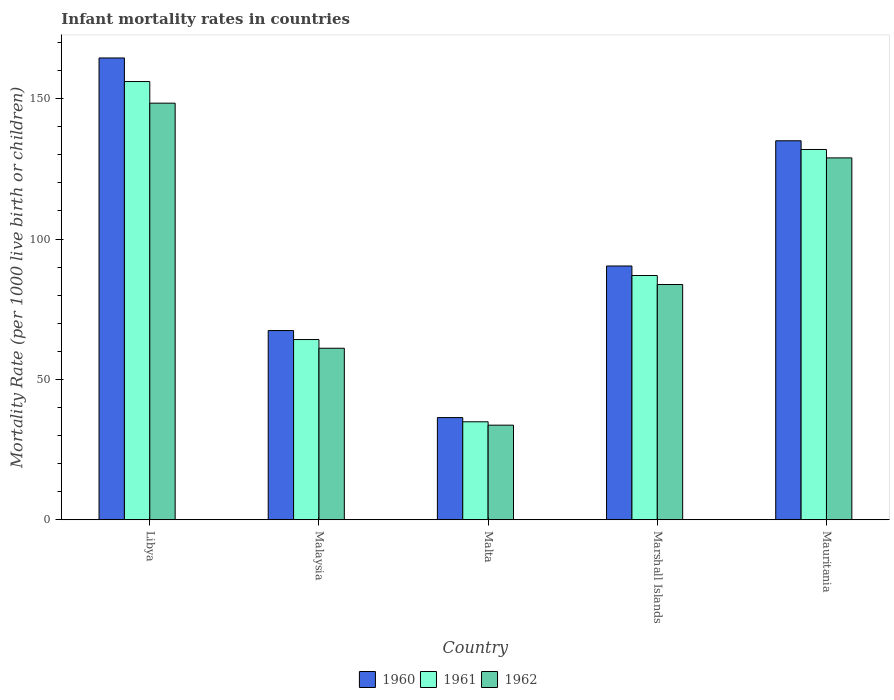How many groups of bars are there?
Give a very brief answer. 5. What is the label of the 1st group of bars from the left?
Provide a short and direct response. Libya. In how many cases, is the number of bars for a given country not equal to the number of legend labels?
Make the answer very short. 0. What is the infant mortality rate in 1962 in Marshall Islands?
Your response must be concise. 83.8. Across all countries, what is the maximum infant mortality rate in 1961?
Your answer should be compact. 156.1. Across all countries, what is the minimum infant mortality rate in 1960?
Provide a short and direct response. 36.4. In which country was the infant mortality rate in 1960 maximum?
Your answer should be compact. Libya. In which country was the infant mortality rate in 1960 minimum?
Offer a terse response. Malta. What is the total infant mortality rate in 1961 in the graph?
Make the answer very short. 474.1. What is the difference between the infant mortality rate in 1962 in Malta and that in Mauritania?
Offer a terse response. -95.2. What is the difference between the infant mortality rate in 1960 in Marshall Islands and the infant mortality rate in 1962 in Libya?
Provide a short and direct response. -58. What is the average infant mortality rate in 1961 per country?
Give a very brief answer. 94.82. What is the difference between the infant mortality rate of/in 1962 and infant mortality rate of/in 1960 in Libya?
Keep it short and to the point. -16.1. In how many countries, is the infant mortality rate in 1962 greater than 160?
Your answer should be very brief. 0. What is the ratio of the infant mortality rate in 1962 in Malaysia to that in Mauritania?
Provide a short and direct response. 0.47. What is the difference between the highest and the second highest infant mortality rate in 1962?
Your answer should be very brief. 45.1. What is the difference between the highest and the lowest infant mortality rate in 1960?
Your answer should be compact. 128.1. In how many countries, is the infant mortality rate in 1961 greater than the average infant mortality rate in 1961 taken over all countries?
Give a very brief answer. 2. Is the sum of the infant mortality rate in 1962 in Malaysia and Mauritania greater than the maximum infant mortality rate in 1961 across all countries?
Provide a short and direct response. Yes. How many countries are there in the graph?
Provide a short and direct response. 5. What is the difference between two consecutive major ticks on the Y-axis?
Provide a succinct answer. 50. Where does the legend appear in the graph?
Provide a succinct answer. Bottom center. How many legend labels are there?
Make the answer very short. 3. What is the title of the graph?
Your answer should be very brief. Infant mortality rates in countries. Does "1995" appear as one of the legend labels in the graph?
Keep it short and to the point. No. What is the label or title of the X-axis?
Make the answer very short. Country. What is the label or title of the Y-axis?
Give a very brief answer. Mortality Rate (per 1000 live birth or children). What is the Mortality Rate (per 1000 live birth or children) of 1960 in Libya?
Your response must be concise. 164.5. What is the Mortality Rate (per 1000 live birth or children) in 1961 in Libya?
Offer a terse response. 156.1. What is the Mortality Rate (per 1000 live birth or children) in 1962 in Libya?
Offer a terse response. 148.4. What is the Mortality Rate (per 1000 live birth or children) of 1960 in Malaysia?
Your answer should be very brief. 67.4. What is the Mortality Rate (per 1000 live birth or children) in 1961 in Malaysia?
Your answer should be very brief. 64.2. What is the Mortality Rate (per 1000 live birth or children) in 1962 in Malaysia?
Offer a very short reply. 61.1. What is the Mortality Rate (per 1000 live birth or children) in 1960 in Malta?
Provide a short and direct response. 36.4. What is the Mortality Rate (per 1000 live birth or children) in 1961 in Malta?
Provide a succinct answer. 34.9. What is the Mortality Rate (per 1000 live birth or children) in 1962 in Malta?
Provide a short and direct response. 33.7. What is the Mortality Rate (per 1000 live birth or children) of 1960 in Marshall Islands?
Make the answer very short. 90.4. What is the Mortality Rate (per 1000 live birth or children) in 1962 in Marshall Islands?
Your answer should be very brief. 83.8. What is the Mortality Rate (per 1000 live birth or children) in 1960 in Mauritania?
Make the answer very short. 135. What is the Mortality Rate (per 1000 live birth or children) in 1961 in Mauritania?
Offer a terse response. 131.9. What is the Mortality Rate (per 1000 live birth or children) of 1962 in Mauritania?
Offer a very short reply. 128.9. Across all countries, what is the maximum Mortality Rate (per 1000 live birth or children) of 1960?
Your response must be concise. 164.5. Across all countries, what is the maximum Mortality Rate (per 1000 live birth or children) in 1961?
Offer a very short reply. 156.1. Across all countries, what is the maximum Mortality Rate (per 1000 live birth or children) of 1962?
Provide a short and direct response. 148.4. Across all countries, what is the minimum Mortality Rate (per 1000 live birth or children) of 1960?
Your response must be concise. 36.4. Across all countries, what is the minimum Mortality Rate (per 1000 live birth or children) in 1961?
Your response must be concise. 34.9. Across all countries, what is the minimum Mortality Rate (per 1000 live birth or children) in 1962?
Provide a succinct answer. 33.7. What is the total Mortality Rate (per 1000 live birth or children) in 1960 in the graph?
Offer a very short reply. 493.7. What is the total Mortality Rate (per 1000 live birth or children) of 1961 in the graph?
Offer a terse response. 474.1. What is the total Mortality Rate (per 1000 live birth or children) of 1962 in the graph?
Ensure brevity in your answer.  455.9. What is the difference between the Mortality Rate (per 1000 live birth or children) in 1960 in Libya and that in Malaysia?
Keep it short and to the point. 97.1. What is the difference between the Mortality Rate (per 1000 live birth or children) of 1961 in Libya and that in Malaysia?
Provide a short and direct response. 91.9. What is the difference between the Mortality Rate (per 1000 live birth or children) in 1962 in Libya and that in Malaysia?
Keep it short and to the point. 87.3. What is the difference between the Mortality Rate (per 1000 live birth or children) of 1960 in Libya and that in Malta?
Your response must be concise. 128.1. What is the difference between the Mortality Rate (per 1000 live birth or children) in 1961 in Libya and that in Malta?
Provide a short and direct response. 121.2. What is the difference between the Mortality Rate (per 1000 live birth or children) of 1962 in Libya and that in Malta?
Your answer should be compact. 114.7. What is the difference between the Mortality Rate (per 1000 live birth or children) in 1960 in Libya and that in Marshall Islands?
Your answer should be compact. 74.1. What is the difference between the Mortality Rate (per 1000 live birth or children) of 1961 in Libya and that in Marshall Islands?
Offer a terse response. 69.1. What is the difference between the Mortality Rate (per 1000 live birth or children) in 1962 in Libya and that in Marshall Islands?
Your answer should be compact. 64.6. What is the difference between the Mortality Rate (per 1000 live birth or children) of 1960 in Libya and that in Mauritania?
Keep it short and to the point. 29.5. What is the difference between the Mortality Rate (per 1000 live birth or children) in 1961 in Libya and that in Mauritania?
Offer a terse response. 24.2. What is the difference between the Mortality Rate (per 1000 live birth or children) in 1961 in Malaysia and that in Malta?
Make the answer very short. 29.3. What is the difference between the Mortality Rate (per 1000 live birth or children) in 1962 in Malaysia and that in Malta?
Make the answer very short. 27.4. What is the difference between the Mortality Rate (per 1000 live birth or children) in 1960 in Malaysia and that in Marshall Islands?
Your answer should be very brief. -23. What is the difference between the Mortality Rate (per 1000 live birth or children) in 1961 in Malaysia and that in Marshall Islands?
Offer a terse response. -22.8. What is the difference between the Mortality Rate (per 1000 live birth or children) in 1962 in Malaysia and that in Marshall Islands?
Ensure brevity in your answer.  -22.7. What is the difference between the Mortality Rate (per 1000 live birth or children) of 1960 in Malaysia and that in Mauritania?
Provide a short and direct response. -67.6. What is the difference between the Mortality Rate (per 1000 live birth or children) of 1961 in Malaysia and that in Mauritania?
Your answer should be compact. -67.7. What is the difference between the Mortality Rate (per 1000 live birth or children) in 1962 in Malaysia and that in Mauritania?
Your answer should be very brief. -67.8. What is the difference between the Mortality Rate (per 1000 live birth or children) of 1960 in Malta and that in Marshall Islands?
Your answer should be very brief. -54. What is the difference between the Mortality Rate (per 1000 live birth or children) of 1961 in Malta and that in Marshall Islands?
Your answer should be compact. -52.1. What is the difference between the Mortality Rate (per 1000 live birth or children) of 1962 in Malta and that in Marshall Islands?
Your answer should be very brief. -50.1. What is the difference between the Mortality Rate (per 1000 live birth or children) in 1960 in Malta and that in Mauritania?
Provide a succinct answer. -98.6. What is the difference between the Mortality Rate (per 1000 live birth or children) in 1961 in Malta and that in Mauritania?
Offer a very short reply. -97. What is the difference between the Mortality Rate (per 1000 live birth or children) in 1962 in Malta and that in Mauritania?
Offer a terse response. -95.2. What is the difference between the Mortality Rate (per 1000 live birth or children) in 1960 in Marshall Islands and that in Mauritania?
Keep it short and to the point. -44.6. What is the difference between the Mortality Rate (per 1000 live birth or children) of 1961 in Marshall Islands and that in Mauritania?
Provide a succinct answer. -44.9. What is the difference between the Mortality Rate (per 1000 live birth or children) in 1962 in Marshall Islands and that in Mauritania?
Your response must be concise. -45.1. What is the difference between the Mortality Rate (per 1000 live birth or children) in 1960 in Libya and the Mortality Rate (per 1000 live birth or children) in 1961 in Malaysia?
Your answer should be compact. 100.3. What is the difference between the Mortality Rate (per 1000 live birth or children) of 1960 in Libya and the Mortality Rate (per 1000 live birth or children) of 1962 in Malaysia?
Offer a very short reply. 103.4. What is the difference between the Mortality Rate (per 1000 live birth or children) in 1960 in Libya and the Mortality Rate (per 1000 live birth or children) in 1961 in Malta?
Make the answer very short. 129.6. What is the difference between the Mortality Rate (per 1000 live birth or children) in 1960 in Libya and the Mortality Rate (per 1000 live birth or children) in 1962 in Malta?
Make the answer very short. 130.8. What is the difference between the Mortality Rate (per 1000 live birth or children) of 1961 in Libya and the Mortality Rate (per 1000 live birth or children) of 1962 in Malta?
Offer a very short reply. 122.4. What is the difference between the Mortality Rate (per 1000 live birth or children) in 1960 in Libya and the Mortality Rate (per 1000 live birth or children) in 1961 in Marshall Islands?
Provide a short and direct response. 77.5. What is the difference between the Mortality Rate (per 1000 live birth or children) in 1960 in Libya and the Mortality Rate (per 1000 live birth or children) in 1962 in Marshall Islands?
Provide a succinct answer. 80.7. What is the difference between the Mortality Rate (per 1000 live birth or children) in 1961 in Libya and the Mortality Rate (per 1000 live birth or children) in 1962 in Marshall Islands?
Keep it short and to the point. 72.3. What is the difference between the Mortality Rate (per 1000 live birth or children) of 1960 in Libya and the Mortality Rate (per 1000 live birth or children) of 1961 in Mauritania?
Give a very brief answer. 32.6. What is the difference between the Mortality Rate (per 1000 live birth or children) in 1960 in Libya and the Mortality Rate (per 1000 live birth or children) in 1962 in Mauritania?
Ensure brevity in your answer.  35.6. What is the difference between the Mortality Rate (per 1000 live birth or children) in 1961 in Libya and the Mortality Rate (per 1000 live birth or children) in 1962 in Mauritania?
Your answer should be compact. 27.2. What is the difference between the Mortality Rate (per 1000 live birth or children) in 1960 in Malaysia and the Mortality Rate (per 1000 live birth or children) in 1961 in Malta?
Provide a succinct answer. 32.5. What is the difference between the Mortality Rate (per 1000 live birth or children) of 1960 in Malaysia and the Mortality Rate (per 1000 live birth or children) of 1962 in Malta?
Your answer should be very brief. 33.7. What is the difference between the Mortality Rate (per 1000 live birth or children) in 1961 in Malaysia and the Mortality Rate (per 1000 live birth or children) in 1962 in Malta?
Keep it short and to the point. 30.5. What is the difference between the Mortality Rate (per 1000 live birth or children) of 1960 in Malaysia and the Mortality Rate (per 1000 live birth or children) of 1961 in Marshall Islands?
Your response must be concise. -19.6. What is the difference between the Mortality Rate (per 1000 live birth or children) of 1960 in Malaysia and the Mortality Rate (per 1000 live birth or children) of 1962 in Marshall Islands?
Your answer should be compact. -16.4. What is the difference between the Mortality Rate (per 1000 live birth or children) in 1961 in Malaysia and the Mortality Rate (per 1000 live birth or children) in 1962 in Marshall Islands?
Provide a succinct answer. -19.6. What is the difference between the Mortality Rate (per 1000 live birth or children) of 1960 in Malaysia and the Mortality Rate (per 1000 live birth or children) of 1961 in Mauritania?
Offer a very short reply. -64.5. What is the difference between the Mortality Rate (per 1000 live birth or children) of 1960 in Malaysia and the Mortality Rate (per 1000 live birth or children) of 1962 in Mauritania?
Provide a short and direct response. -61.5. What is the difference between the Mortality Rate (per 1000 live birth or children) of 1961 in Malaysia and the Mortality Rate (per 1000 live birth or children) of 1962 in Mauritania?
Ensure brevity in your answer.  -64.7. What is the difference between the Mortality Rate (per 1000 live birth or children) in 1960 in Malta and the Mortality Rate (per 1000 live birth or children) in 1961 in Marshall Islands?
Provide a succinct answer. -50.6. What is the difference between the Mortality Rate (per 1000 live birth or children) of 1960 in Malta and the Mortality Rate (per 1000 live birth or children) of 1962 in Marshall Islands?
Make the answer very short. -47.4. What is the difference between the Mortality Rate (per 1000 live birth or children) in 1961 in Malta and the Mortality Rate (per 1000 live birth or children) in 1962 in Marshall Islands?
Your answer should be very brief. -48.9. What is the difference between the Mortality Rate (per 1000 live birth or children) in 1960 in Malta and the Mortality Rate (per 1000 live birth or children) in 1961 in Mauritania?
Keep it short and to the point. -95.5. What is the difference between the Mortality Rate (per 1000 live birth or children) in 1960 in Malta and the Mortality Rate (per 1000 live birth or children) in 1962 in Mauritania?
Make the answer very short. -92.5. What is the difference between the Mortality Rate (per 1000 live birth or children) in 1961 in Malta and the Mortality Rate (per 1000 live birth or children) in 1962 in Mauritania?
Offer a very short reply. -94. What is the difference between the Mortality Rate (per 1000 live birth or children) of 1960 in Marshall Islands and the Mortality Rate (per 1000 live birth or children) of 1961 in Mauritania?
Your answer should be very brief. -41.5. What is the difference between the Mortality Rate (per 1000 live birth or children) of 1960 in Marshall Islands and the Mortality Rate (per 1000 live birth or children) of 1962 in Mauritania?
Provide a short and direct response. -38.5. What is the difference between the Mortality Rate (per 1000 live birth or children) of 1961 in Marshall Islands and the Mortality Rate (per 1000 live birth or children) of 1962 in Mauritania?
Provide a short and direct response. -41.9. What is the average Mortality Rate (per 1000 live birth or children) of 1960 per country?
Your answer should be very brief. 98.74. What is the average Mortality Rate (per 1000 live birth or children) of 1961 per country?
Offer a very short reply. 94.82. What is the average Mortality Rate (per 1000 live birth or children) in 1962 per country?
Provide a succinct answer. 91.18. What is the difference between the Mortality Rate (per 1000 live birth or children) in 1960 and Mortality Rate (per 1000 live birth or children) in 1961 in Libya?
Provide a succinct answer. 8.4. What is the difference between the Mortality Rate (per 1000 live birth or children) in 1960 and Mortality Rate (per 1000 live birth or children) in 1962 in Libya?
Provide a succinct answer. 16.1. What is the difference between the Mortality Rate (per 1000 live birth or children) of 1961 and Mortality Rate (per 1000 live birth or children) of 1962 in Libya?
Provide a succinct answer. 7.7. What is the difference between the Mortality Rate (per 1000 live birth or children) of 1960 and Mortality Rate (per 1000 live birth or children) of 1961 in Malaysia?
Give a very brief answer. 3.2. What is the difference between the Mortality Rate (per 1000 live birth or children) in 1960 and Mortality Rate (per 1000 live birth or children) in 1962 in Malaysia?
Provide a short and direct response. 6.3. What is the difference between the Mortality Rate (per 1000 live birth or children) of 1960 and Mortality Rate (per 1000 live birth or children) of 1962 in Malta?
Provide a short and direct response. 2.7. What is the difference between the Mortality Rate (per 1000 live birth or children) in 1961 and Mortality Rate (per 1000 live birth or children) in 1962 in Malta?
Ensure brevity in your answer.  1.2. What is the ratio of the Mortality Rate (per 1000 live birth or children) of 1960 in Libya to that in Malaysia?
Provide a succinct answer. 2.44. What is the ratio of the Mortality Rate (per 1000 live birth or children) in 1961 in Libya to that in Malaysia?
Provide a short and direct response. 2.43. What is the ratio of the Mortality Rate (per 1000 live birth or children) in 1962 in Libya to that in Malaysia?
Provide a succinct answer. 2.43. What is the ratio of the Mortality Rate (per 1000 live birth or children) in 1960 in Libya to that in Malta?
Your answer should be compact. 4.52. What is the ratio of the Mortality Rate (per 1000 live birth or children) of 1961 in Libya to that in Malta?
Provide a succinct answer. 4.47. What is the ratio of the Mortality Rate (per 1000 live birth or children) in 1962 in Libya to that in Malta?
Provide a succinct answer. 4.4. What is the ratio of the Mortality Rate (per 1000 live birth or children) in 1960 in Libya to that in Marshall Islands?
Your answer should be very brief. 1.82. What is the ratio of the Mortality Rate (per 1000 live birth or children) of 1961 in Libya to that in Marshall Islands?
Ensure brevity in your answer.  1.79. What is the ratio of the Mortality Rate (per 1000 live birth or children) in 1962 in Libya to that in Marshall Islands?
Provide a succinct answer. 1.77. What is the ratio of the Mortality Rate (per 1000 live birth or children) of 1960 in Libya to that in Mauritania?
Keep it short and to the point. 1.22. What is the ratio of the Mortality Rate (per 1000 live birth or children) of 1961 in Libya to that in Mauritania?
Your answer should be compact. 1.18. What is the ratio of the Mortality Rate (per 1000 live birth or children) of 1962 in Libya to that in Mauritania?
Provide a short and direct response. 1.15. What is the ratio of the Mortality Rate (per 1000 live birth or children) of 1960 in Malaysia to that in Malta?
Offer a very short reply. 1.85. What is the ratio of the Mortality Rate (per 1000 live birth or children) of 1961 in Malaysia to that in Malta?
Offer a terse response. 1.84. What is the ratio of the Mortality Rate (per 1000 live birth or children) in 1962 in Malaysia to that in Malta?
Give a very brief answer. 1.81. What is the ratio of the Mortality Rate (per 1000 live birth or children) in 1960 in Malaysia to that in Marshall Islands?
Your response must be concise. 0.75. What is the ratio of the Mortality Rate (per 1000 live birth or children) of 1961 in Malaysia to that in Marshall Islands?
Ensure brevity in your answer.  0.74. What is the ratio of the Mortality Rate (per 1000 live birth or children) of 1962 in Malaysia to that in Marshall Islands?
Offer a terse response. 0.73. What is the ratio of the Mortality Rate (per 1000 live birth or children) in 1960 in Malaysia to that in Mauritania?
Provide a short and direct response. 0.5. What is the ratio of the Mortality Rate (per 1000 live birth or children) of 1961 in Malaysia to that in Mauritania?
Give a very brief answer. 0.49. What is the ratio of the Mortality Rate (per 1000 live birth or children) in 1962 in Malaysia to that in Mauritania?
Keep it short and to the point. 0.47. What is the ratio of the Mortality Rate (per 1000 live birth or children) of 1960 in Malta to that in Marshall Islands?
Offer a terse response. 0.4. What is the ratio of the Mortality Rate (per 1000 live birth or children) in 1961 in Malta to that in Marshall Islands?
Provide a short and direct response. 0.4. What is the ratio of the Mortality Rate (per 1000 live birth or children) in 1962 in Malta to that in Marshall Islands?
Provide a short and direct response. 0.4. What is the ratio of the Mortality Rate (per 1000 live birth or children) in 1960 in Malta to that in Mauritania?
Your response must be concise. 0.27. What is the ratio of the Mortality Rate (per 1000 live birth or children) of 1961 in Malta to that in Mauritania?
Your answer should be compact. 0.26. What is the ratio of the Mortality Rate (per 1000 live birth or children) of 1962 in Malta to that in Mauritania?
Give a very brief answer. 0.26. What is the ratio of the Mortality Rate (per 1000 live birth or children) of 1960 in Marshall Islands to that in Mauritania?
Offer a very short reply. 0.67. What is the ratio of the Mortality Rate (per 1000 live birth or children) of 1961 in Marshall Islands to that in Mauritania?
Your response must be concise. 0.66. What is the ratio of the Mortality Rate (per 1000 live birth or children) of 1962 in Marshall Islands to that in Mauritania?
Make the answer very short. 0.65. What is the difference between the highest and the second highest Mortality Rate (per 1000 live birth or children) of 1960?
Offer a terse response. 29.5. What is the difference between the highest and the second highest Mortality Rate (per 1000 live birth or children) in 1961?
Offer a terse response. 24.2. What is the difference between the highest and the second highest Mortality Rate (per 1000 live birth or children) of 1962?
Your answer should be very brief. 19.5. What is the difference between the highest and the lowest Mortality Rate (per 1000 live birth or children) in 1960?
Offer a terse response. 128.1. What is the difference between the highest and the lowest Mortality Rate (per 1000 live birth or children) of 1961?
Your answer should be very brief. 121.2. What is the difference between the highest and the lowest Mortality Rate (per 1000 live birth or children) of 1962?
Provide a short and direct response. 114.7. 